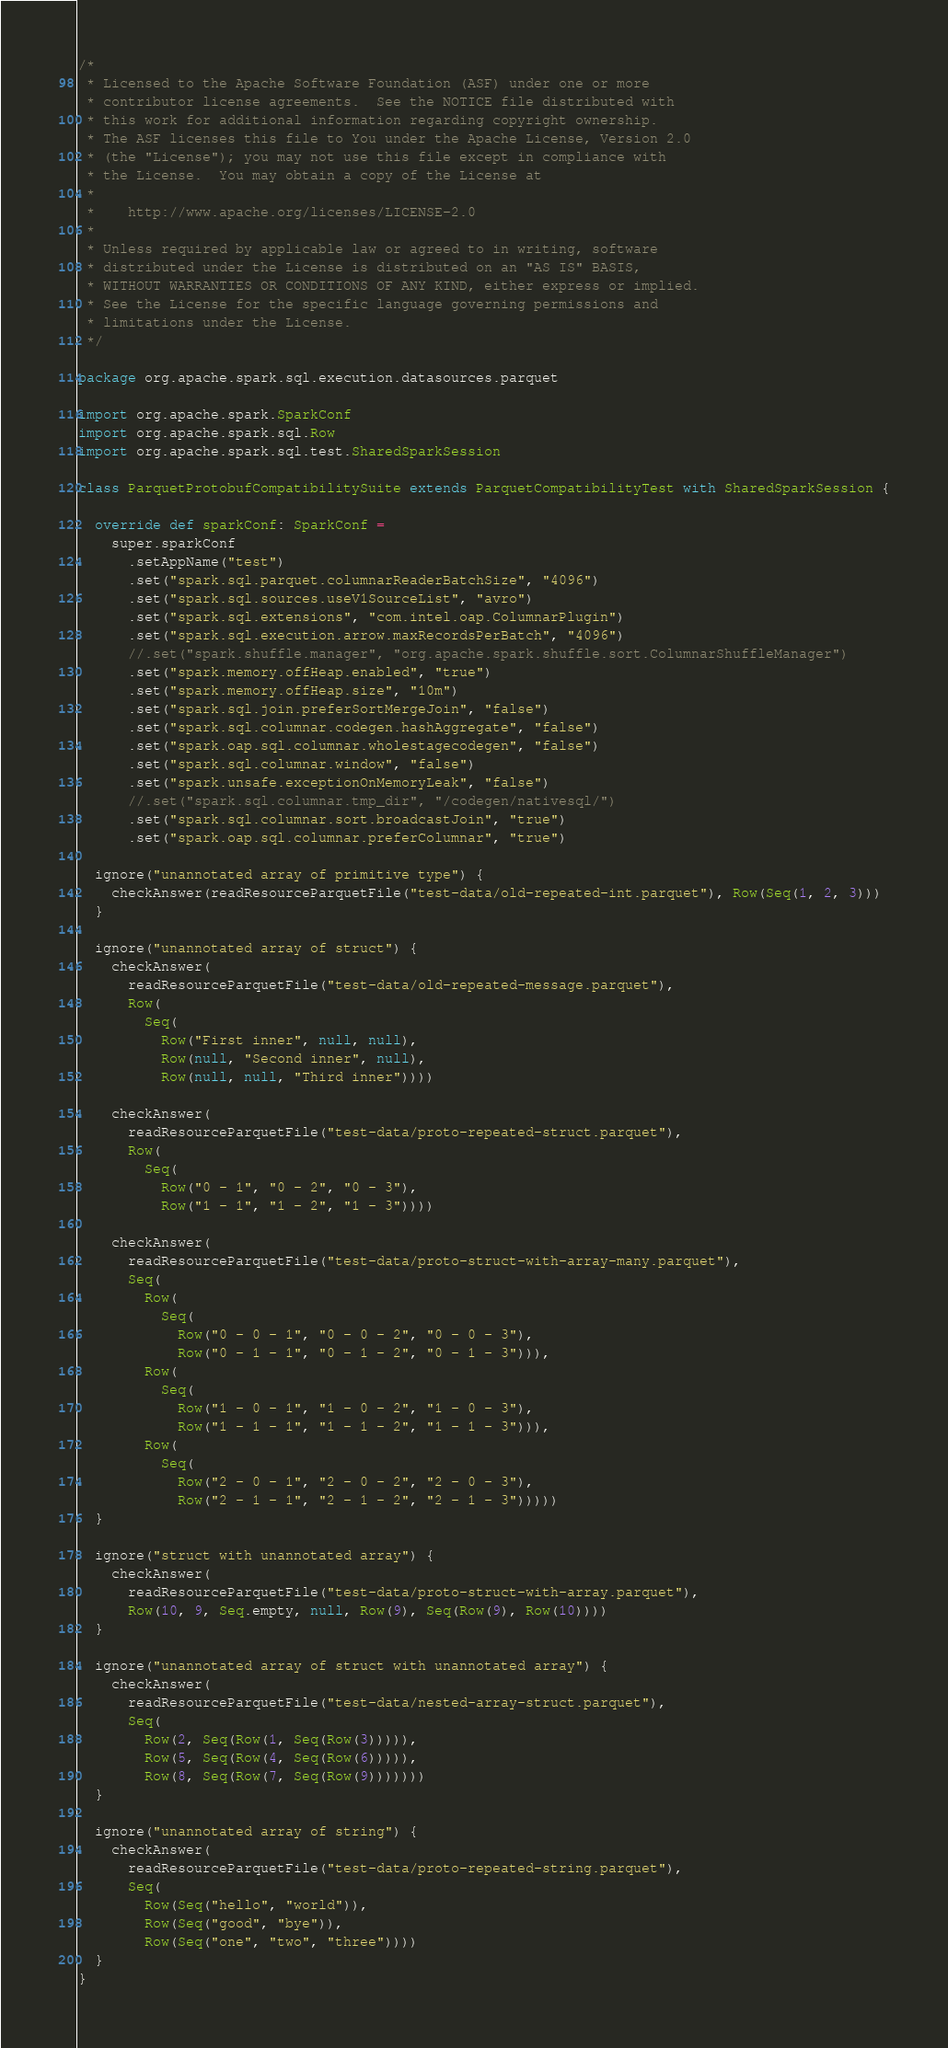Convert code to text. <code><loc_0><loc_0><loc_500><loc_500><_Scala_>/*
 * Licensed to the Apache Software Foundation (ASF) under one or more
 * contributor license agreements.  See the NOTICE file distributed with
 * this work for additional information regarding copyright ownership.
 * The ASF licenses this file to You under the Apache License, Version 2.0
 * (the "License"); you may not use this file except in compliance with
 * the License.  You may obtain a copy of the License at
 *
 *    http://www.apache.org/licenses/LICENSE-2.0
 *
 * Unless required by applicable law or agreed to in writing, software
 * distributed under the License is distributed on an "AS IS" BASIS,
 * WITHOUT WARRANTIES OR CONDITIONS OF ANY KIND, either express or implied.
 * See the License for the specific language governing permissions and
 * limitations under the License.
 */

package org.apache.spark.sql.execution.datasources.parquet

import org.apache.spark.SparkConf
import org.apache.spark.sql.Row
import org.apache.spark.sql.test.SharedSparkSession

class ParquetProtobufCompatibilitySuite extends ParquetCompatibilityTest with SharedSparkSession {

  override def sparkConf: SparkConf =
    super.sparkConf
      .setAppName("test")
      .set("spark.sql.parquet.columnarReaderBatchSize", "4096")
      .set("spark.sql.sources.useV1SourceList", "avro")
      .set("spark.sql.extensions", "com.intel.oap.ColumnarPlugin")
      .set("spark.sql.execution.arrow.maxRecordsPerBatch", "4096")
      //.set("spark.shuffle.manager", "org.apache.spark.shuffle.sort.ColumnarShuffleManager")
      .set("spark.memory.offHeap.enabled", "true")
      .set("spark.memory.offHeap.size", "10m")
      .set("spark.sql.join.preferSortMergeJoin", "false")
      .set("spark.sql.columnar.codegen.hashAggregate", "false")
      .set("spark.oap.sql.columnar.wholestagecodegen", "false")
      .set("spark.sql.columnar.window", "false")
      .set("spark.unsafe.exceptionOnMemoryLeak", "false")
      //.set("spark.sql.columnar.tmp_dir", "/codegen/nativesql/")
      .set("spark.sql.columnar.sort.broadcastJoin", "true")
      .set("spark.oap.sql.columnar.preferColumnar", "true")

  ignore("unannotated array of primitive type") {
    checkAnswer(readResourceParquetFile("test-data/old-repeated-int.parquet"), Row(Seq(1, 2, 3)))
  }

  ignore("unannotated array of struct") {
    checkAnswer(
      readResourceParquetFile("test-data/old-repeated-message.parquet"),
      Row(
        Seq(
          Row("First inner", null, null),
          Row(null, "Second inner", null),
          Row(null, null, "Third inner"))))

    checkAnswer(
      readResourceParquetFile("test-data/proto-repeated-struct.parquet"),
      Row(
        Seq(
          Row("0 - 1", "0 - 2", "0 - 3"),
          Row("1 - 1", "1 - 2", "1 - 3"))))

    checkAnswer(
      readResourceParquetFile("test-data/proto-struct-with-array-many.parquet"),
      Seq(
        Row(
          Seq(
            Row("0 - 0 - 1", "0 - 0 - 2", "0 - 0 - 3"),
            Row("0 - 1 - 1", "0 - 1 - 2", "0 - 1 - 3"))),
        Row(
          Seq(
            Row("1 - 0 - 1", "1 - 0 - 2", "1 - 0 - 3"),
            Row("1 - 1 - 1", "1 - 1 - 2", "1 - 1 - 3"))),
        Row(
          Seq(
            Row("2 - 0 - 1", "2 - 0 - 2", "2 - 0 - 3"),
            Row("2 - 1 - 1", "2 - 1 - 2", "2 - 1 - 3")))))
  }

  ignore("struct with unannotated array") {
    checkAnswer(
      readResourceParquetFile("test-data/proto-struct-with-array.parquet"),
      Row(10, 9, Seq.empty, null, Row(9), Seq(Row(9), Row(10))))
  }

  ignore("unannotated array of struct with unannotated array") {
    checkAnswer(
      readResourceParquetFile("test-data/nested-array-struct.parquet"),
      Seq(
        Row(2, Seq(Row(1, Seq(Row(3))))),
        Row(5, Seq(Row(4, Seq(Row(6))))),
        Row(8, Seq(Row(7, Seq(Row(9)))))))
  }

  ignore("unannotated array of string") {
    checkAnswer(
      readResourceParquetFile("test-data/proto-repeated-string.parquet"),
      Seq(
        Row(Seq("hello", "world")),
        Row(Seq("good", "bye")),
        Row(Seq("one", "two", "three"))))
  }
}
</code> 